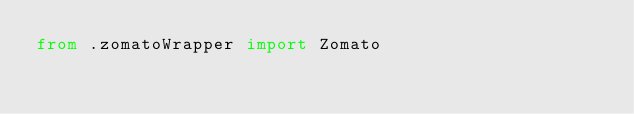<code> <loc_0><loc_0><loc_500><loc_500><_Python_>from .zomatoWrapper import Zomato</code> 